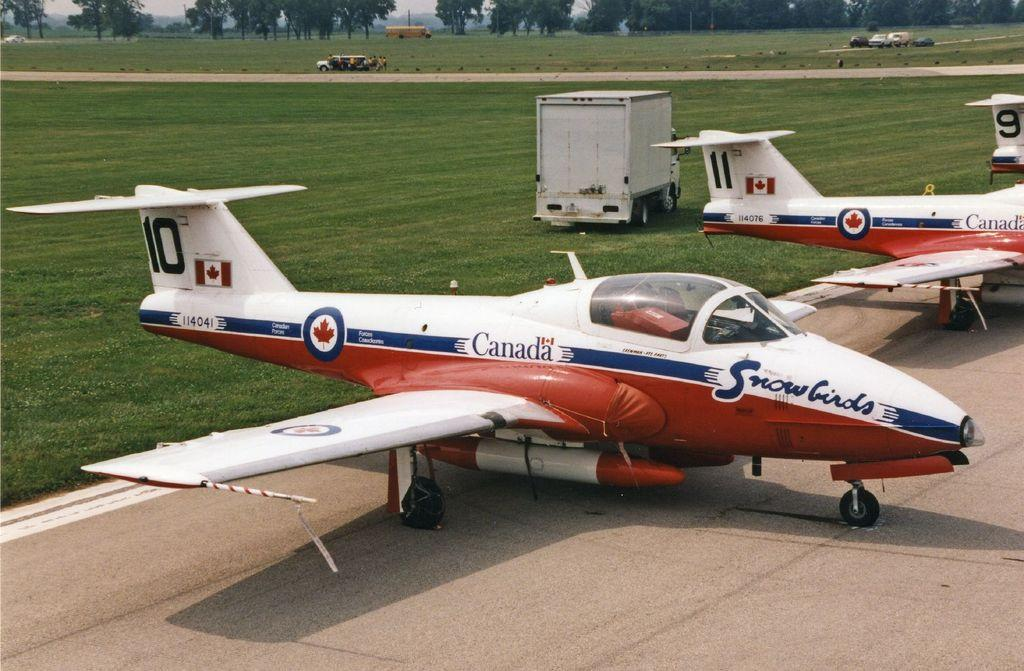<image>
Present a compact description of the photo's key features. Canadian planes are lined up side by side 